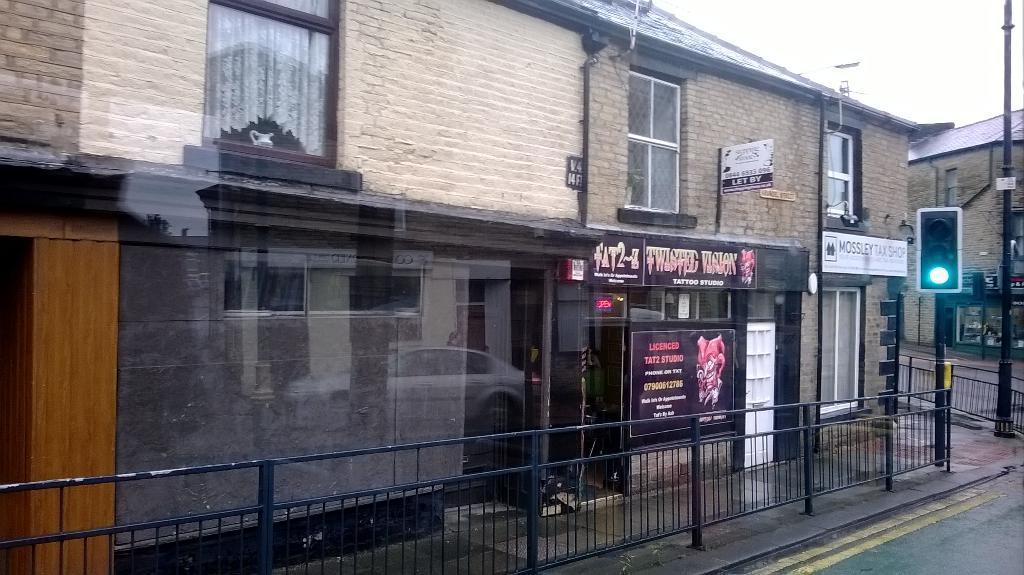Can you describe this image briefly? In this image in the center there is a railing. In the background there are buildings and there are boards with some text written on it and there are poles and there is a green light reflecting from the signal and there are windows and there is a glass and on the glass there is a reflection of the car. 